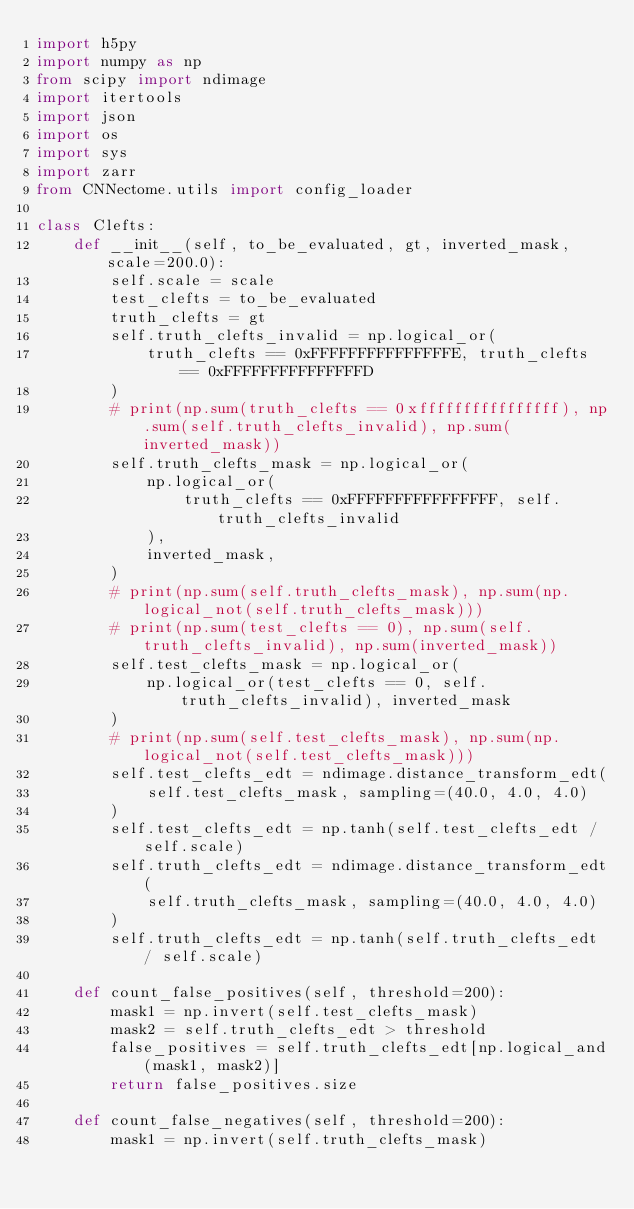<code> <loc_0><loc_0><loc_500><loc_500><_Python_>import h5py
import numpy as np
from scipy import ndimage
import itertools
import json
import os
import sys
import zarr
from CNNectome.utils import config_loader

class Clefts:
    def __init__(self, to_be_evaluated, gt, inverted_mask, scale=200.0):
        self.scale = scale
        test_clefts = to_be_evaluated
        truth_clefts = gt
        self.truth_clefts_invalid = np.logical_or(
            truth_clefts == 0xFFFFFFFFFFFFFFFE, truth_clefts == 0xFFFFFFFFFFFFFFFD
        )
        # print(np.sum(truth_clefts == 0xffffffffffffffff), np.sum(self.truth_clefts_invalid), np.sum(inverted_mask))
        self.truth_clefts_mask = np.logical_or(
            np.logical_or(
                truth_clefts == 0xFFFFFFFFFFFFFFFF, self.truth_clefts_invalid
            ),
            inverted_mask,
        )
        # print(np.sum(self.truth_clefts_mask), np.sum(np.logical_not(self.truth_clefts_mask)))
        # print(np.sum(test_clefts == 0), np.sum(self.truth_clefts_invalid), np.sum(inverted_mask))
        self.test_clefts_mask = np.logical_or(
            np.logical_or(test_clefts == 0, self.truth_clefts_invalid), inverted_mask
        )
        # print(np.sum(self.test_clefts_mask), np.sum(np.logical_not(self.test_clefts_mask)))
        self.test_clefts_edt = ndimage.distance_transform_edt(
            self.test_clefts_mask, sampling=(40.0, 4.0, 4.0)
        )
        self.test_clefts_edt = np.tanh(self.test_clefts_edt / self.scale)
        self.truth_clefts_edt = ndimage.distance_transform_edt(
            self.truth_clefts_mask, sampling=(40.0, 4.0, 4.0)
        )
        self.truth_clefts_edt = np.tanh(self.truth_clefts_edt / self.scale)

    def count_false_positives(self, threshold=200):
        mask1 = np.invert(self.test_clefts_mask)
        mask2 = self.truth_clefts_edt > threshold
        false_positives = self.truth_clefts_edt[np.logical_and(mask1, mask2)]
        return false_positives.size

    def count_false_negatives(self, threshold=200):
        mask1 = np.invert(self.truth_clefts_mask)</code> 